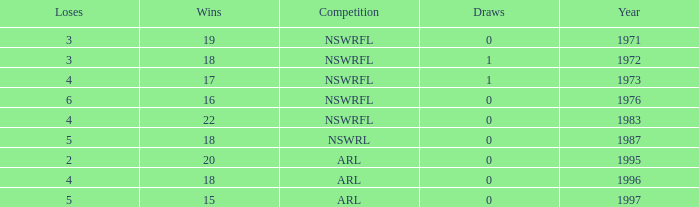What average Loses has Draws less than 0? None. 